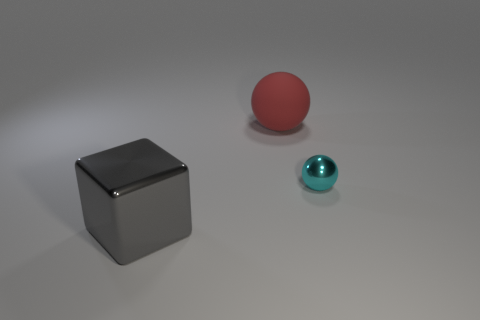Add 3 tiny cyan shiny cubes. How many objects exist? 6 Subtract all balls. How many objects are left? 1 Subtract all big red balls. Subtract all small spheres. How many objects are left? 1 Add 1 cyan balls. How many cyan balls are left? 2 Add 2 tiny cyan balls. How many tiny cyan balls exist? 3 Subtract 0 yellow cubes. How many objects are left? 3 